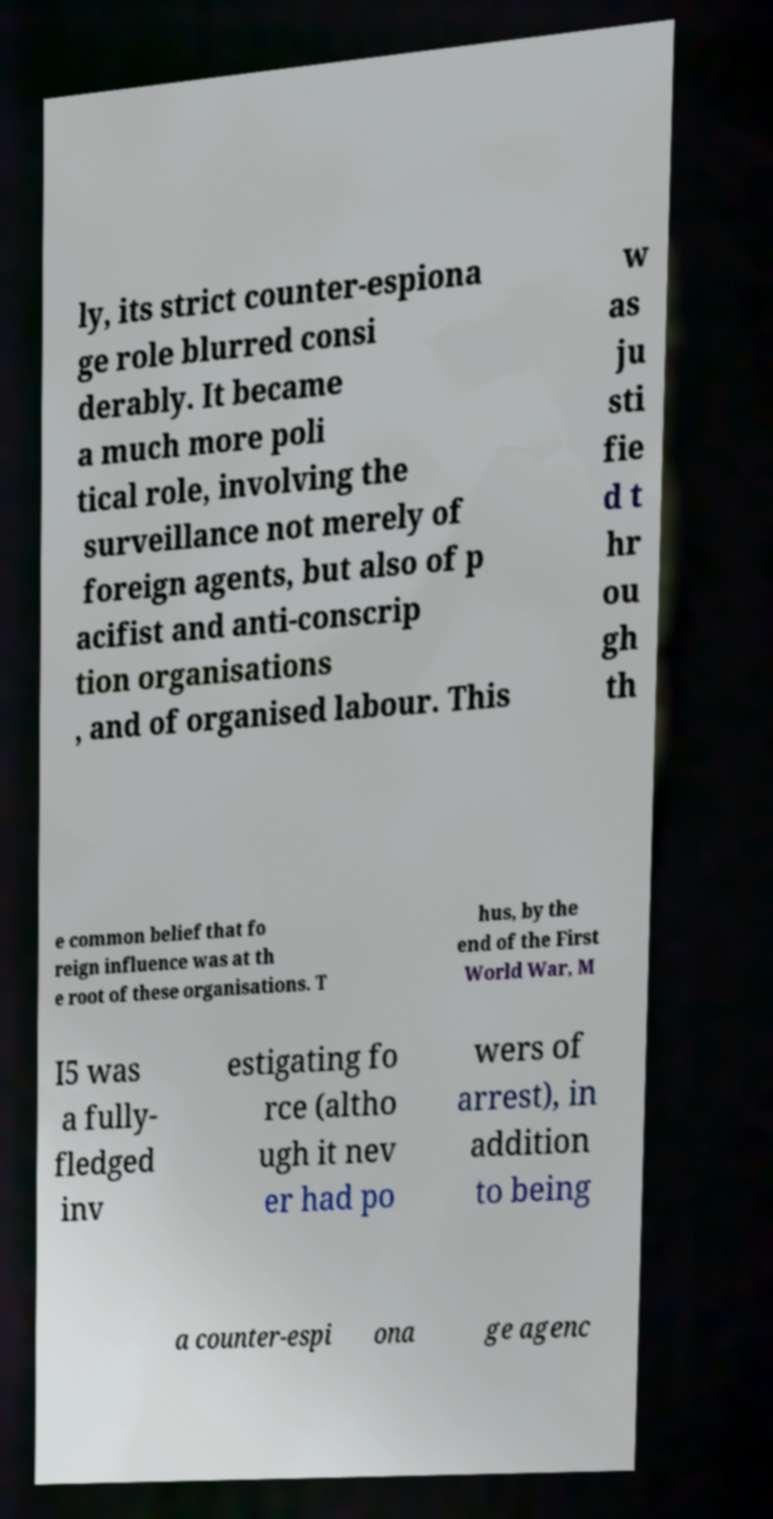What messages or text are displayed in this image? I need them in a readable, typed format. ly, its strict counter-espiona ge role blurred consi derably. It became a much more poli tical role, involving the surveillance not merely of foreign agents, but also of p acifist and anti-conscrip tion organisations , and of organised labour. This w as ju sti fie d t hr ou gh th e common belief that fo reign influence was at th e root of these organisations. T hus, by the end of the First World War, M I5 was a fully- fledged inv estigating fo rce (altho ugh it nev er had po wers of arrest), in addition to being a counter-espi ona ge agenc 